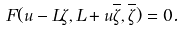<formula> <loc_0><loc_0><loc_500><loc_500>F ( u - L \zeta , L + u \overline { \zeta } , \overline { \zeta } ) = 0 .</formula> 